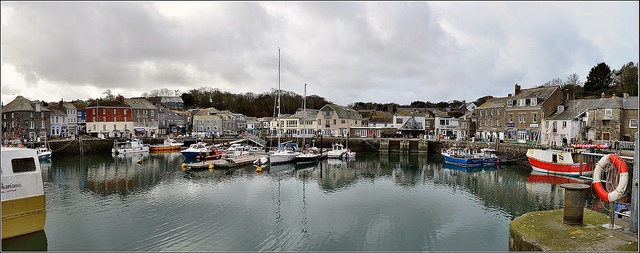Describe the objects in this image and their specific colors. I can see boat in black, lightgray, red, brown, and darkgray tones, boat in black, gray, darkgray, and navy tones, boat in black, darkgray, gray, and lightgray tones, boat in black, gray, darkgray, and lightgray tones, and boat in black, lightgray, darkgray, and gray tones in this image. 